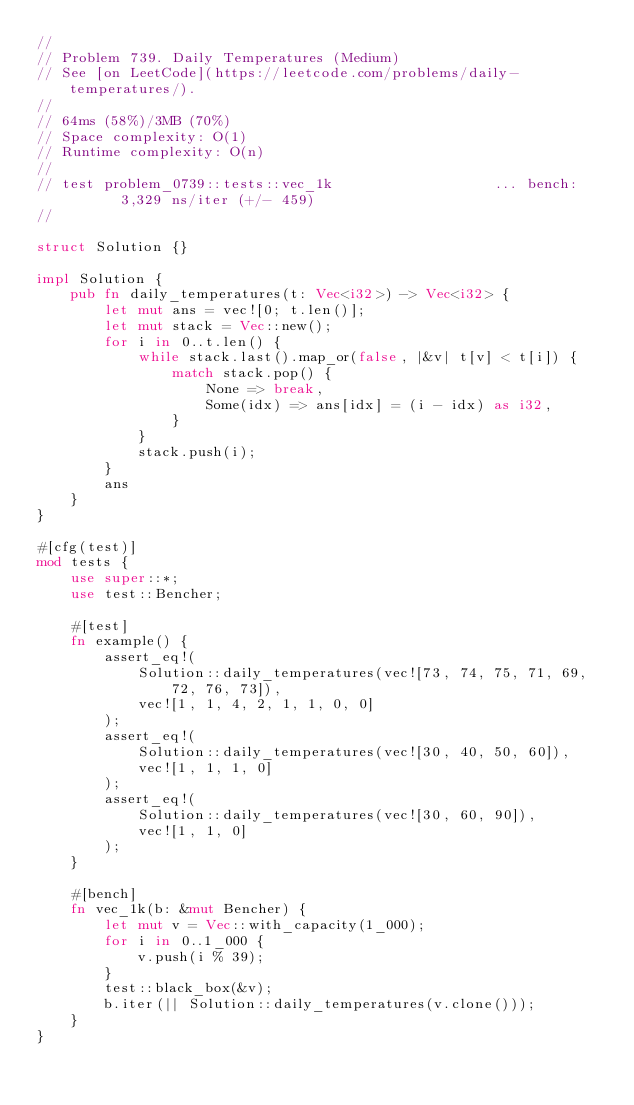<code> <loc_0><loc_0><loc_500><loc_500><_Rust_>//
// Problem 739. Daily Temperatures (Medium)
// See [on LeetCode](https://leetcode.com/problems/daily-temperatures/).
//
// 64ms (58%)/3MB (70%)
// Space complexity: O(1)
// Runtime complexity: O(n)
//
// test problem_0739::tests::vec_1k                   ... bench:       3,329 ns/iter (+/- 459)
//

struct Solution {}

impl Solution {
    pub fn daily_temperatures(t: Vec<i32>) -> Vec<i32> {
        let mut ans = vec![0; t.len()];
        let mut stack = Vec::new();
        for i in 0..t.len() {
            while stack.last().map_or(false, |&v| t[v] < t[i]) {
                match stack.pop() {
                    None => break,
                    Some(idx) => ans[idx] = (i - idx) as i32,
                }
            }
            stack.push(i);
        }
        ans
    }
}

#[cfg(test)]
mod tests {
    use super::*;
    use test::Bencher;

    #[test]
    fn example() {
        assert_eq!(
            Solution::daily_temperatures(vec![73, 74, 75, 71, 69, 72, 76, 73]),
            vec![1, 1, 4, 2, 1, 1, 0, 0]
        );
        assert_eq!(
            Solution::daily_temperatures(vec![30, 40, 50, 60]),
            vec![1, 1, 1, 0]
        );
        assert_eq!(
            Solution::daily_temperatures(vec![30, 60, 90]),
            vec![1, 1, 0]
        );
    }

    #[bench]
    fn vec_1k(b: &mut Bencher) {
        let mut v = Vec::with_capacity(1_000);
        for i in 0..1_000 {
            v.push(i % 39);
        }
        test::black_box(&v);
        b.iter(|| Solution::daily_temperatures(v.clone()));
    }
}
</code> 